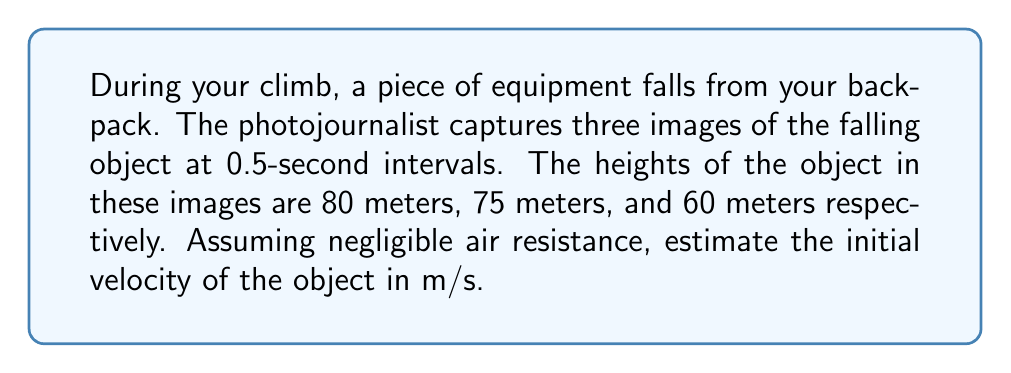Give your solution to this math problem. To solve this problem, we'll use the equations of motion for a falling object under constant acceleration due to gravity. Let's follow these steps:

1) First, recall the equation for position as a function of time for an object under constant acceleration:

   $$y(t) = y_0 + v_0t - \frac{1}{2}gt^2$$

   Where $y_0$ is the initial position, $v_0$ is the initial velocity, $g$ is the acceleration due to gravity (approximately 9.8 m/s²), and $t$ is time.

2) We have three data points:
   - At t = 0 s: y = 80 m
   - At t = 0.5 s: y = 75 m
   - At t = 1 s: y = 60 m

3) Let's use the first and last data points to set up our equation:

   $$60 = 80 + v_0(1) - \frac{1}{2}(9.8)(1)^2$$

4) Simplify:

   $$60 = 80 + v_0 - 4.9$$
   $$-15.1 = v_0$$

5) To verify, let's check if this initial velocity satisfies the middle data point:

   $$75 = 80 + (-15.1)(0.5) - \frac{1}{2}(9.8)(0.5)^2$$
   $$75 = 80 - 7.55 - 1.225$$
   $$75 = 71.225$$

6) The slight discrepancy (3.775 m) can be attributed to measurement error or slight air resistance.

Therefore, the initial velocity of the falling object is approximately -15.1 m/s.
Answer: -15.1 m/s 